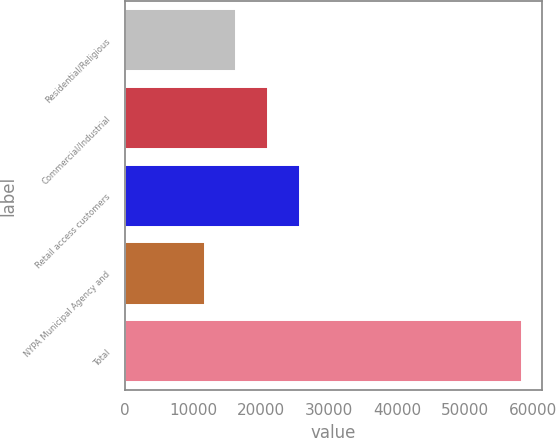Convert chart. <chart><loc_0><loc_0><loc_500><loc_500><bar_chart><fcel>Residential/Religious<fcel>Commercial/Industrial<fcel>Retail access customers<fcel>NYPA Municipal Agency and<fcel>Total<nl><fcel>16365.9<fcel>21027.8<fcel>25689.7<fcel>11704<fcel>58323<nl></chart> 